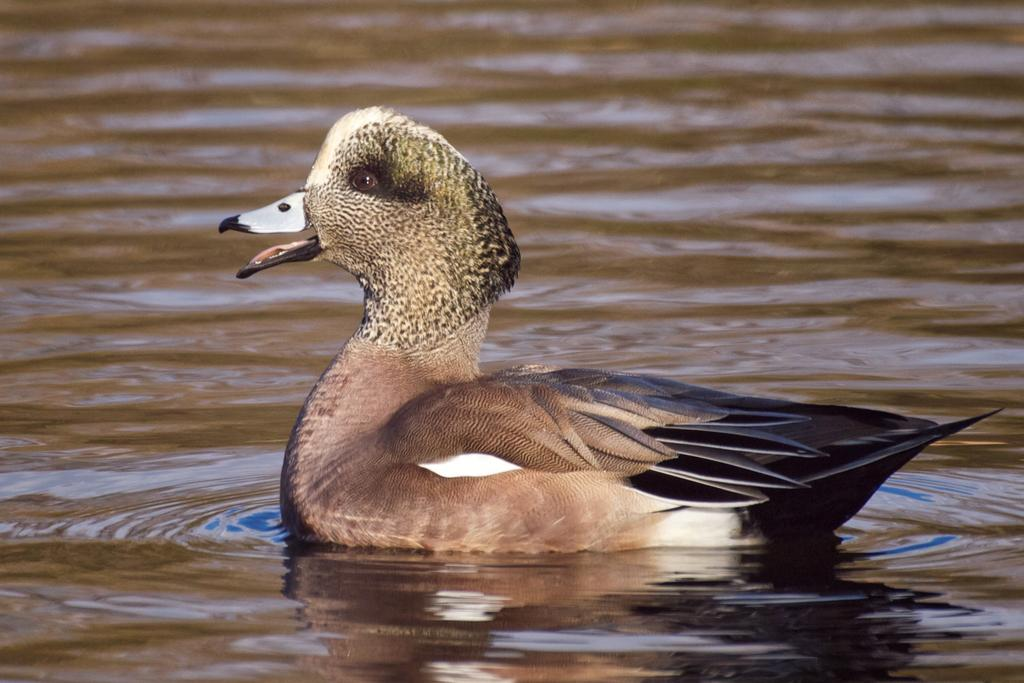What animal is present in the image? There is a duck in the image. Where is the duck located? The duck is on the water. What type of pies can be seen on the table in the image? There is no table or pies present in the image; it features a duck on the water. 